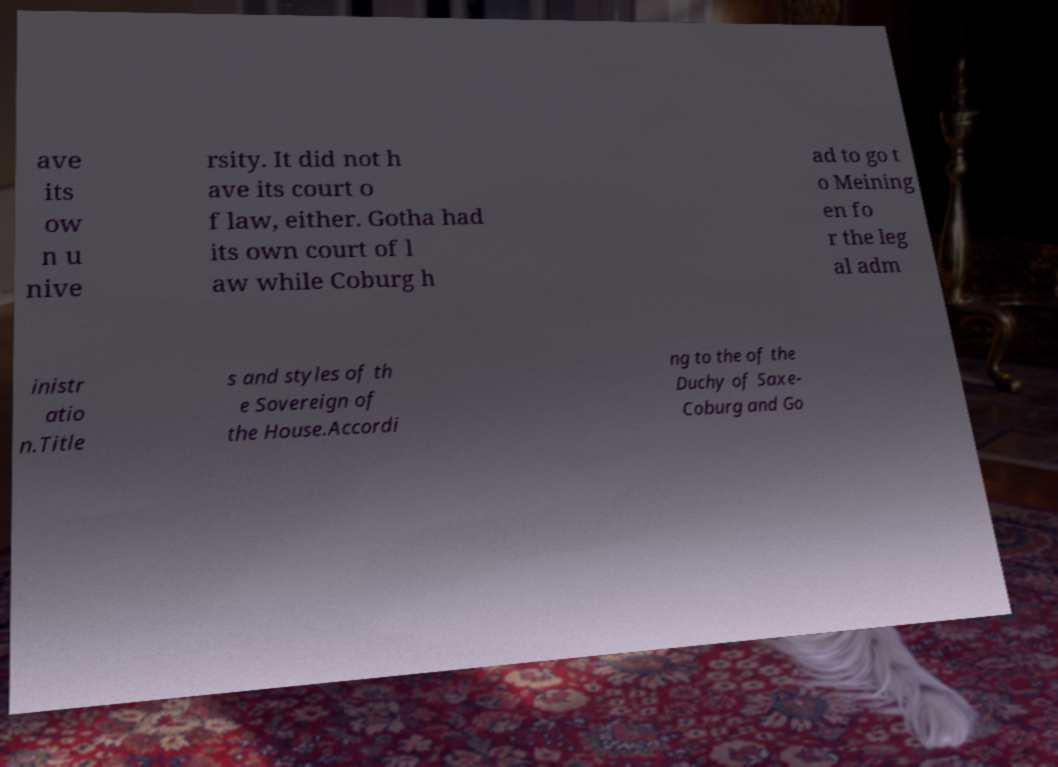Can you read and provide the text displayed in the image?This photo seems to have some interesting text. Can you extract and type it out for me? ave its ow n u nive rsity. It did not h ave its court o f law, either. Gotha had its own court of l aw while Coburg h ad to go t o Meining en fo r the leg al adm inistr atio n.Title s and styles of th e Sovereign of the House.Accordi ng to the of the Duchy of Saxe- Coburg and Go 